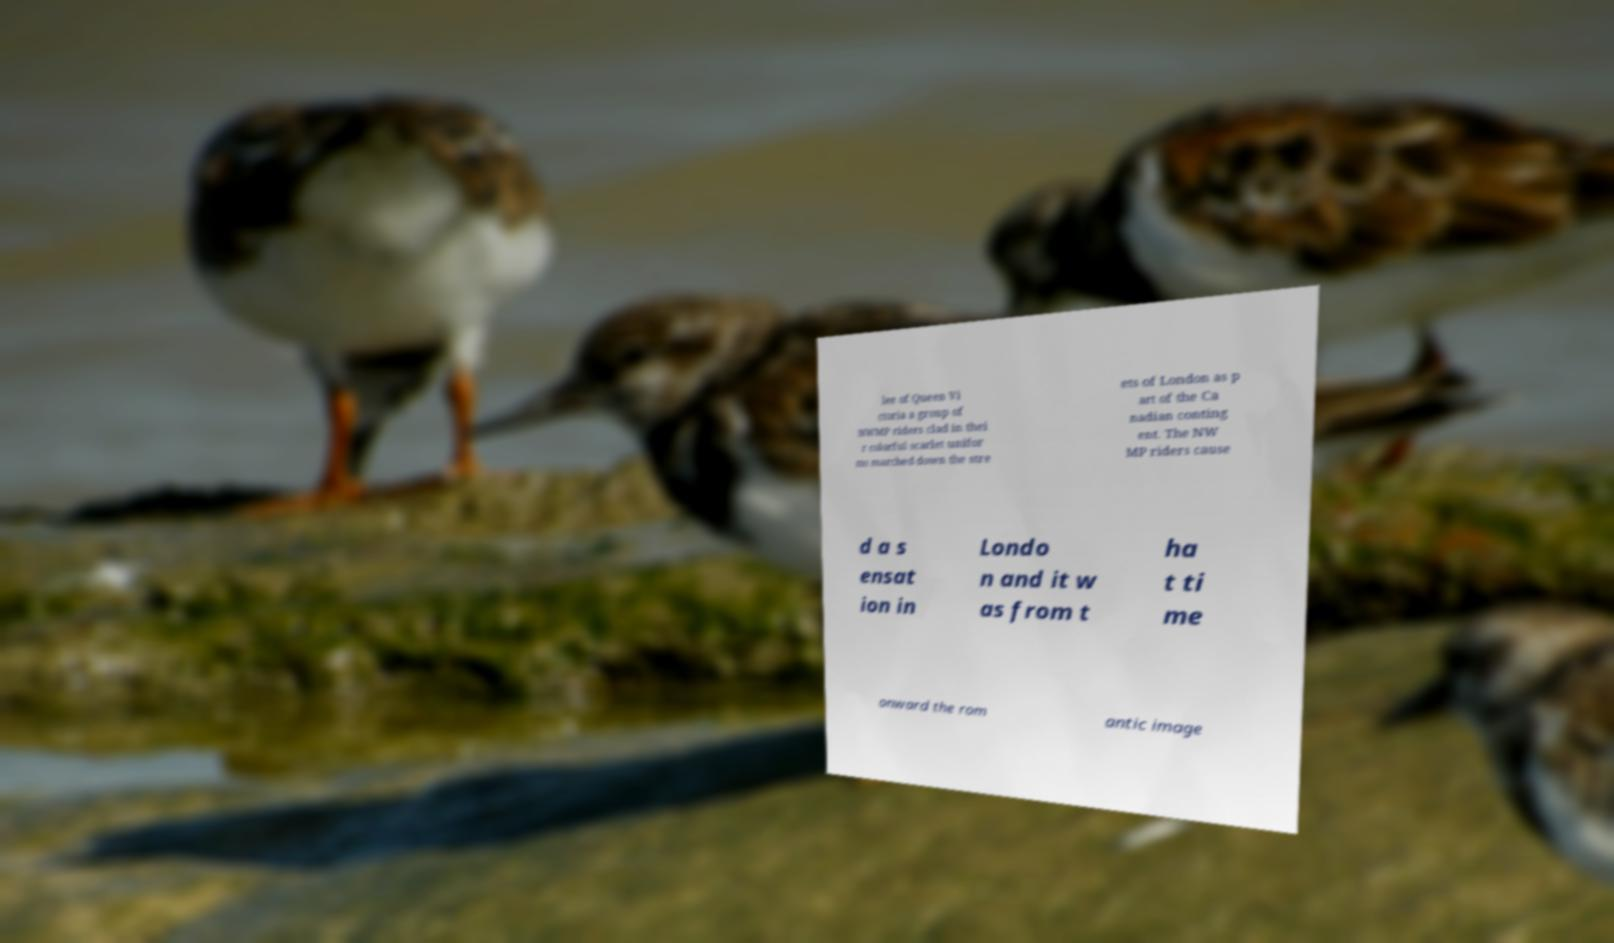For documentation purposes, I need the text within this image transcribed. Could you provide that? lee of Queen Vi ctoria a group of NWMP riders clad in thei r colorful scarlet unifor ms marched down the stre ets of London as p art of the Ca nadian conting ent. The NW MP riders cause d a s ensat ion in Londo n and it w as from t ha t ti me onward the rom antic image 